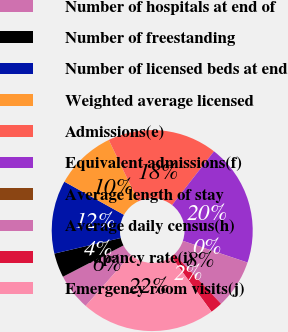<chart> <loc_0><loc_0><loc_500><loc_500><pie_chart><fcel>Number of hospitals at end of<fcel>Number of freestanding<fcel>Number of licensed beds at end<fcel>Weighted average licensed<fcel>Admissions(e)<fcel>Equivalent admissions(f)<fcel>Average length of stay<fcel>Average daily census(h)<fcel>Occupancy rate(i)<fcel>Emergency room visits(j)<nl><fcel>5.88%<fcel>3.92%<fcel>11.76%<fcel>9.8%<fcel>17.65%<fcel>19.61%<fcel>0.0%<fcel>7.84%<fcel>1.96%<fcel>21.57%<nl></chart> 